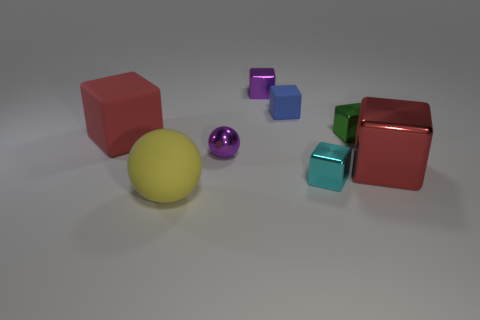There is a small metallic cube behind the blue object; is there a tiny cyan cube on the left side of it?
Your response must be concise. No. Is there a rubber object of the same size as the green metallic thing?
Ensure brevity in your answer.  Yes. Do the big block right of the small purple sphere and the large rubber block have the same color?
Make the answer very short. Yes. What size is the green thing?
Your answer should be very brief. Small. What size is the purple object behind the large red object to the left of the big yellow ball?
Your response must be concise. Small. What number of other big matte cubes have the same color as the big matte block?
Give a very brief answer. 0. What number of big green balls are there?
Make the answer very short. 0. How many big red things are made of the same material as the yellow sphere?
Provide a short and direct response. 1. There is a red metal object that is the same shape as the tiny cyan metallic object; what size is it?
Your answer should be compact. Large. What material is the large yellow thing?
Give a very brief answer. Rubber. 